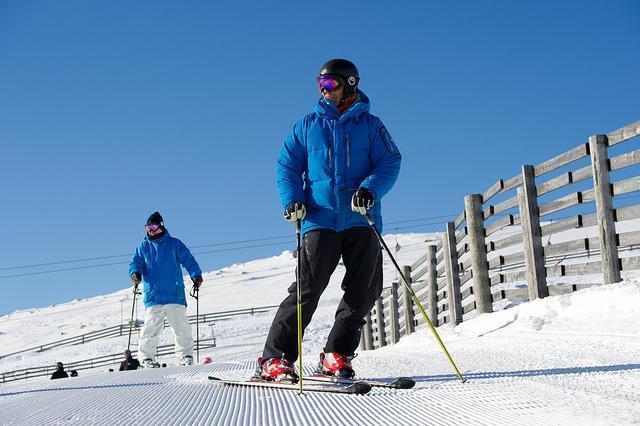What made the grooves seen here?
Select the accurate response from the four choices given to answer the question.
Options: Skis, gophers, snow groomer, children. Snow groomer. 